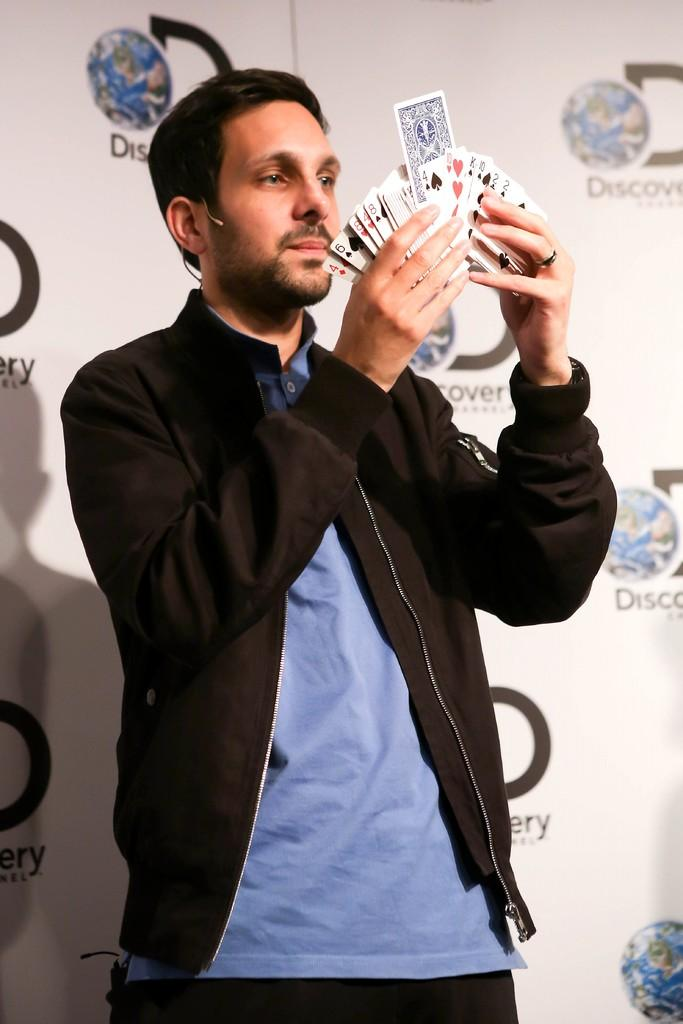Who is the main subject in the image? There is a man in the center of the image. What is the man doing in the image? The man is standing and holding some cards. What can be seen in the background of the image? There is a wall in the background of the image. What type of reaction can be seen from the mailbox in the image? There is no mailbox present in the image, so it is not possible to determine any reaction from it. 